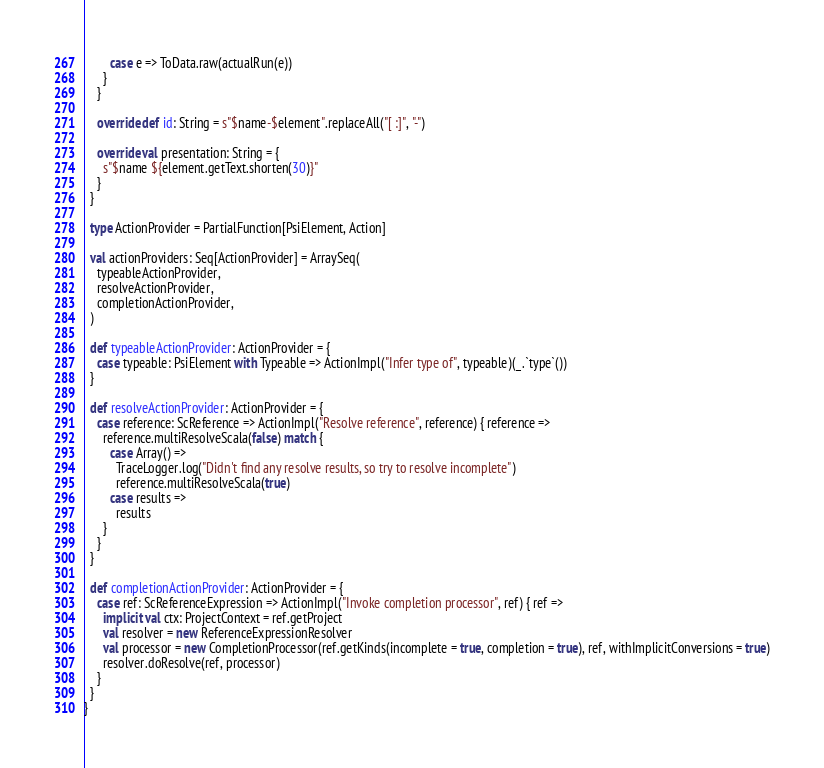Convert code to text. <code><loc_0><loc_0><loc_500><loc_500><_Scala_>        case e => ToData.raw(actualRun(e))
      }
    }

    override def id: String = s"$name-$element".replaceAll("[ :]", "-")

    override val presentation: String = {
      s"$name ${element.getText.shorten(30)}"
    }
  }

  type ActionProvider = PartialFunction[PsiElement, Action]

  val actionProviders: Seq[ActionProvider] = ArraySeq(
    typeableActionProvider,
    resolveActionProvider,
    completionActionProvider,
  )

  def typeableActionProvider: ActionProvider = {
    case typeable: PsiElement with Typeable => ActionImpl("Infer type of", typeable)(_.`type`())
  }

  def resolveActionProvider: ActionProvider = {
    case reference: ScReference => ActionImpl("Resolve reference", reference) { reference =>
      reference.multiResolveScala(false) match {
        case Array() =>
          TraceLogger.log("Didn't find any resolve results, so try to resolve incomplete")
          reference.multiResolveScala(true)
        case results =>
          results
      }
    }
  }

  def completionActionProvider: ActionProvider = {
    case ref: ScReferenceExpression => ActionImpl("Invoke completion processor", ref) { ref =>
      implicit val ctx: ProjectContext = ref.getProject
      val resolver = new ReferenceExpressionResolver
      val processor = new CompletionProcessor(ref.getKinds(incomplete = true, completion = true), ref, withImplicitConversions = true)
      resolver.doResolve(ref, processor)
    }
  }
}
</code> 